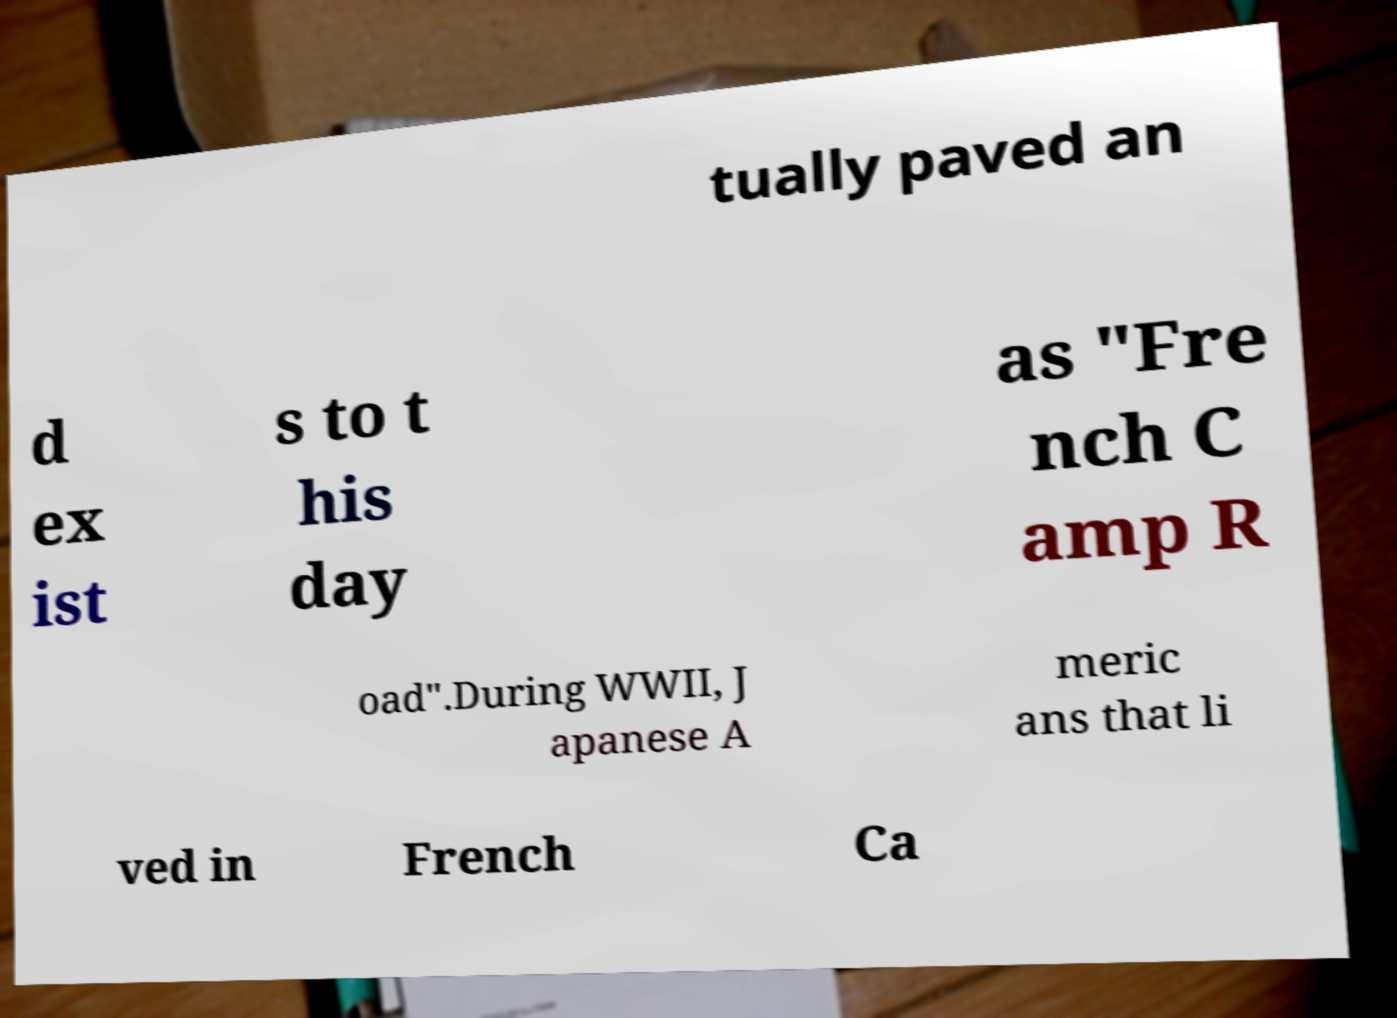What messages or text are displayed in this image? I need them in a readable, typed format. tually paved an d ex ist s to t his day as "Fre nch C amp R oad".During WWII, J apanese A meric ans that li ved in French Ca 